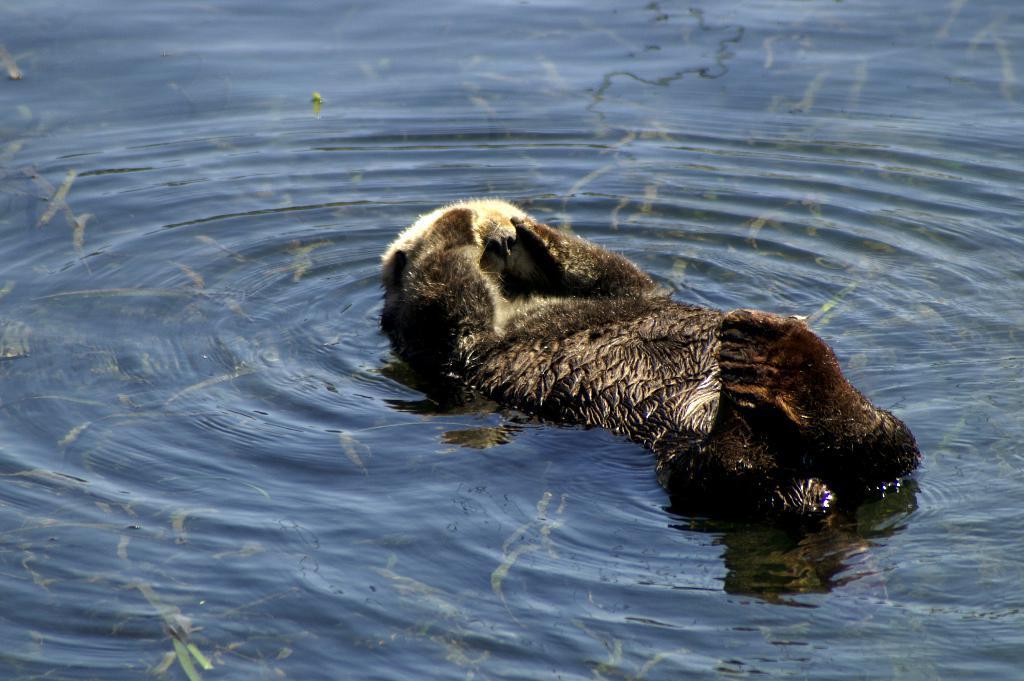How would you summarize this image in a sentence or two? Here in this picture we can see a sea otter present in the water and we can also see under water plants present. 